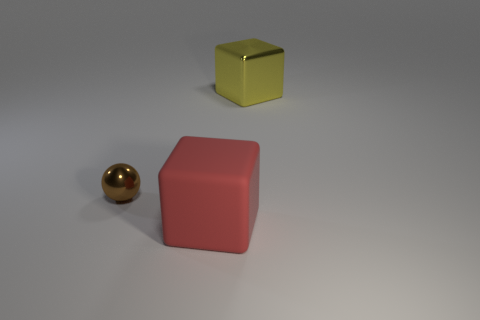Is there anything else that has the same size as the metallic sphere?
Keep it short and to the point. No. Are there more cubes behind the small brown metal thing than yellow cubes right of the yellow shiny object?
Make the answer very short. Yes. Are there any metal spheres right of the large red block?
Ensure brevity in your answer.  No. What is the tiny brown thing made of?
Keep it short and to the point. Metal. There is a object that is to the left of the big rubber block; what is its shape?
Make the answer very short. Sphere. Are there any yellow cubes that have the same size as the red rubber block?
Your response must be concise. Yes. Are the large thing behind the tiny metallic thing and the small thing made of the same material?
Provide a succinct answer. Yes. Is the number of brown metallic balls right of the red block the same as the number of small brown metallic spheres in front of the tiny shiny thing?
Make the answer very short. Yes. There is a thing that is both on the right side of the ball and left of the yellow block; what shape is it?
Give a very brief answer. Cube. There is a sphere; how many red matte blocks are in front of it?
Give a very brief answer. 1. 